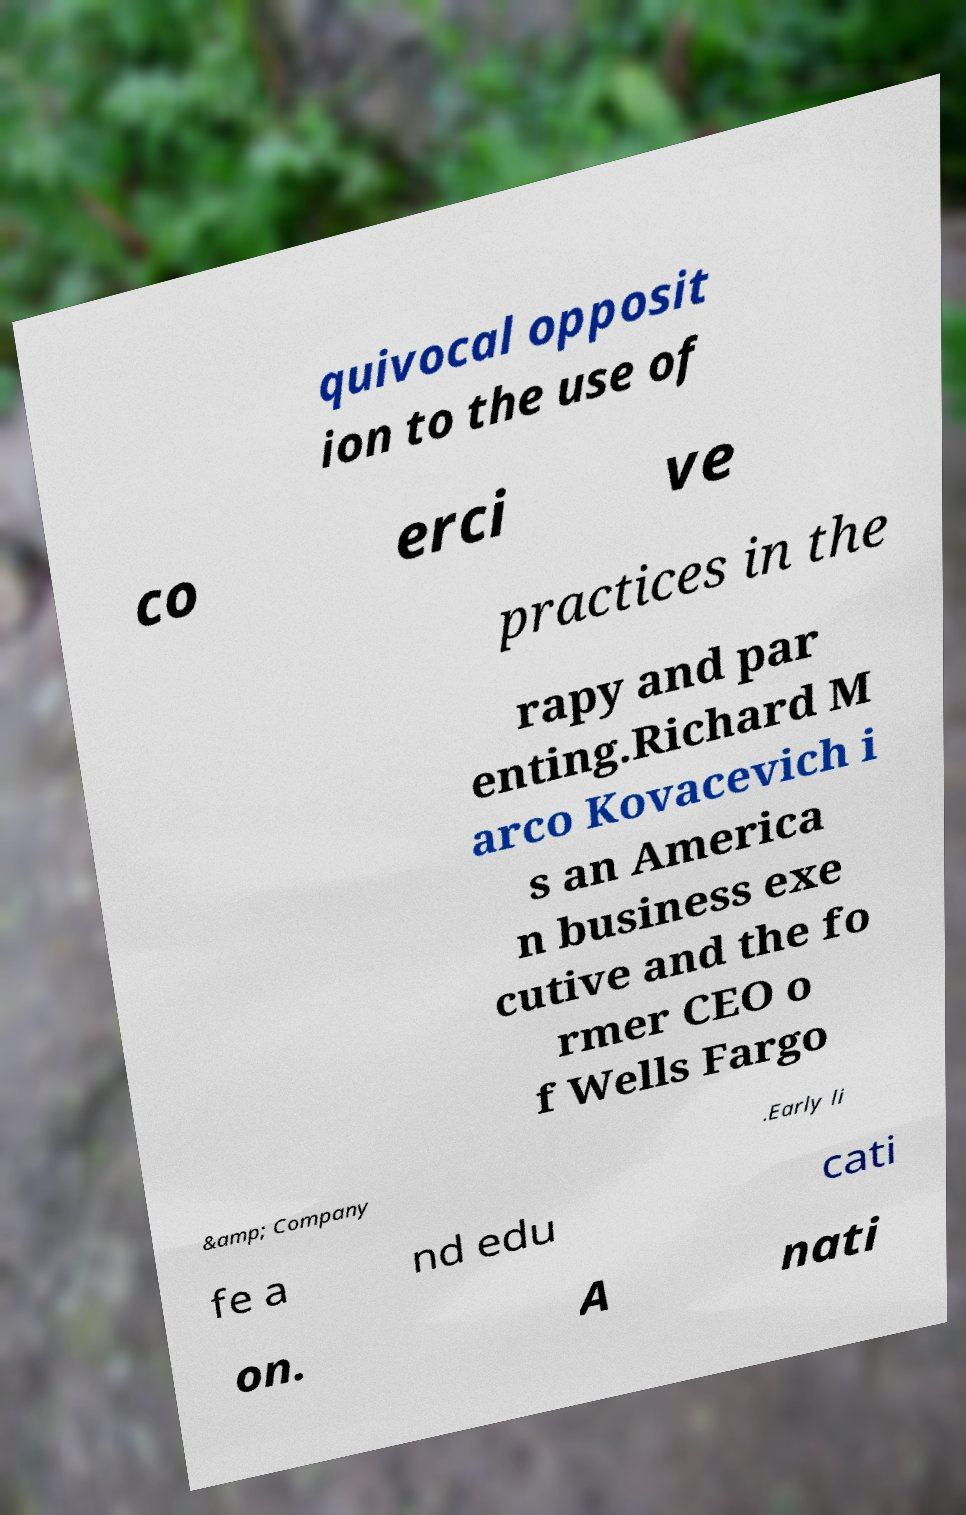Could you extract and type out the text from this image? quivocal opposit ion to the use of co erci ve practices in the rapy and par enting.Richard M arco Kovacevich i s an America n business exe cutive and the fo rmer CEO o f Wells Fargo &amp; Company .Early li fe a nd edu cati on. A nati 